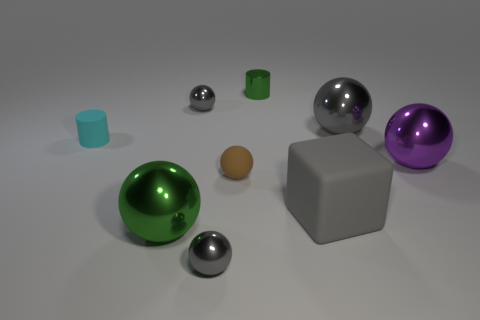Subtract all big gray spheres. How many spheres are left? 5 Subtract all purple balls. How many balls are left? 5 Add 1 green spheres. How many green spheres are left? 2 Add 1 small metal cylinders. How many small metal cylinders exist? 2 Subtract 0 yellow cylinders. How many objects are left? 9 Subtract all cubes. How many objects are left? 8 Subtract 1 cubes. How many cubes are left? 0 Subtract all purple cylinders. Subtract all yellow cubes. How many cylinders are left? 2 Subtract all red cubes. How many green spheres are left? 1 Subtract all green balls. Subtract all purple shiny objects. How many objects are left? 7 